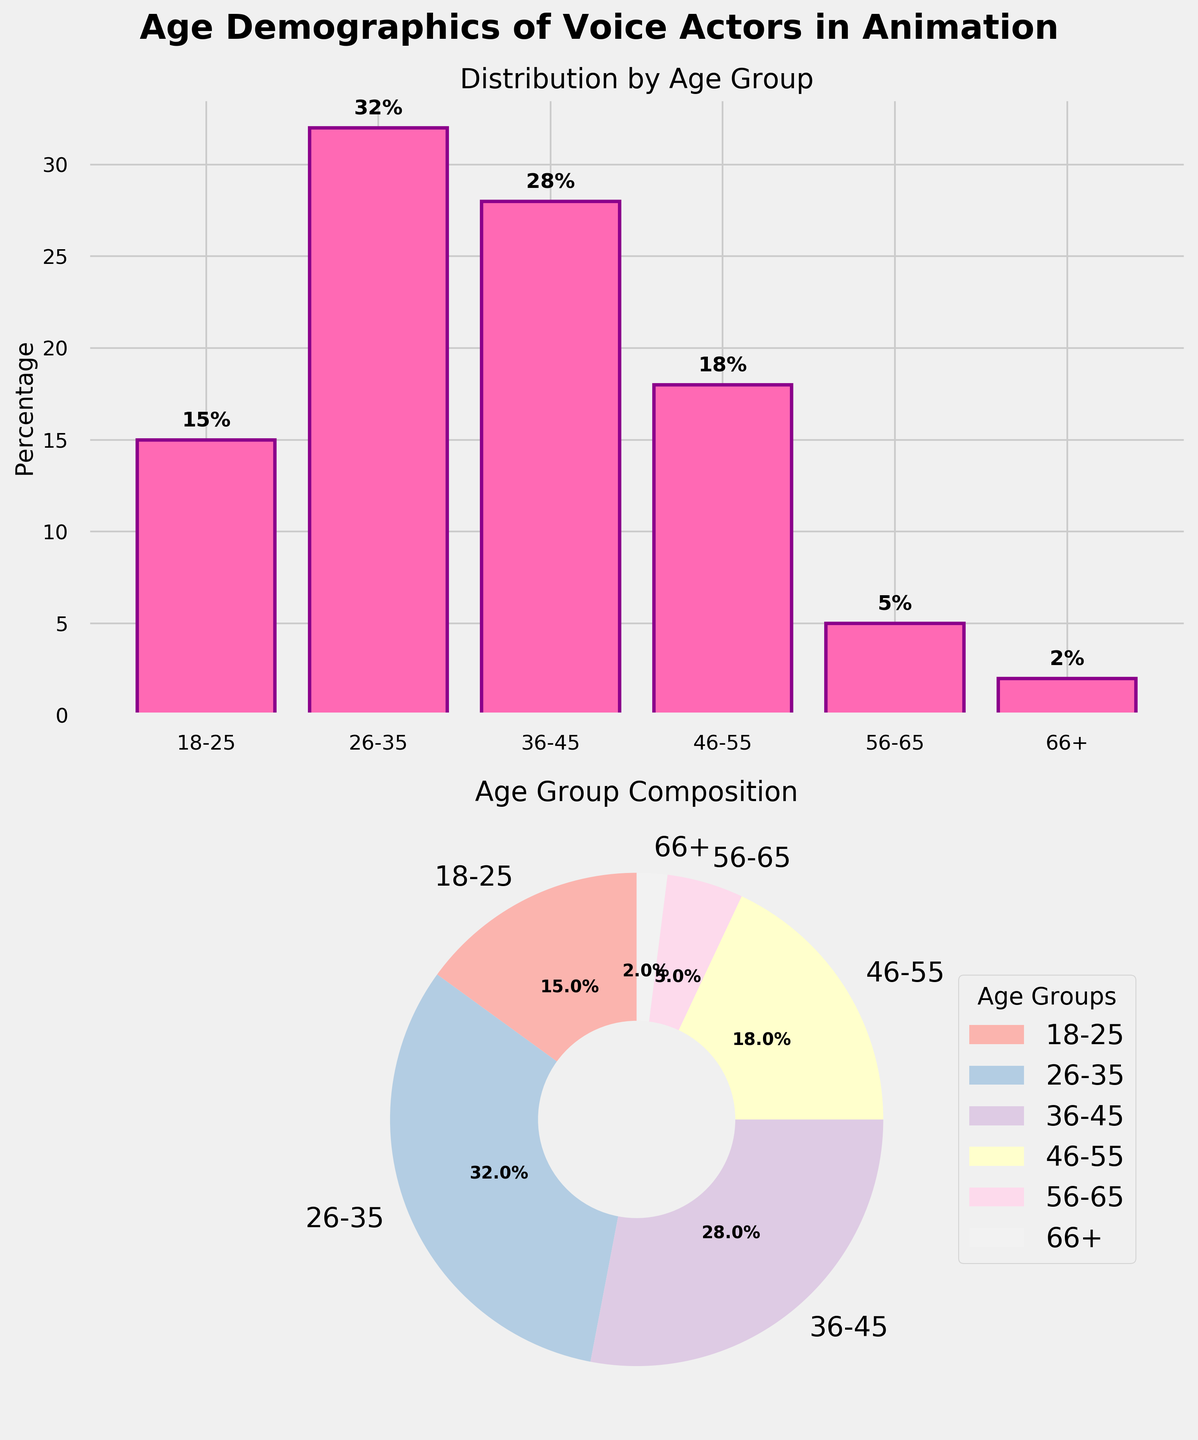What's the title of the figure? The title is generally located at the top of the figure. In this case, it is explicitly mentioned in the code that the title is "Age Demographics of Voice Actors in Animation".
Answer: Age Demographics of Voice Actors in Animation Which age group has the highest percentage? By looking at the bar plot, the tallest bar represents the age group with the highest percentage. Additionally, the pie chart percentage values indicate that the highest percentage belongs to the age group 26-35.
Answer: 26-35 What percentage of voice actors are 56-65 years old? Locate the bar corresponding to the age group 56-65 on the bar plot or look for the pie chart slice labeled 56-65. The percentage value next to it is 5%.
Answer: 5% How does the percentage of voice actors aged 18-25 compare to those aged 46-55? By comparing the heights of the bars or the slices in the pie chart, the bar corresponding to age 46-55 is taller and has a higher percentage value than the bar for age 18-25. Specifically, the percentages are 18% for 46-55 and 15% for 18-25.
Answer: 46-55 is higher What is the combined percentage of voice actors aged 36-45 and 46-55? Sum the percentages of the age groups 36-45 and 46-55. From the figure, 36-45 is 28% and 46-55 is 18%. Adding them gives 28% + 18% = 46%.
Answer: 46% Which age group makes up only 2% of the voice actors? Both the bar plot and the pie chart show an age group with a small slice or a short bar. The label on this smallest category indicates '66+' and is noted as 2%.
Answer: 66+ How is the data shown differently in the two subplots? The bar plot on the top subplot shows percentages as vertical bars with each bar's height representing the percentage. The pie chart on the bottom subplot shows the data as slices of a circle where each slice corresponds to a percentage and labels indicate the respective age group.
Answer: Bar plot and pie chart Which age group holds exactly 32% of the demographic? On the bar plot, find the bar with the label and height representing 32%. Alternatively, look for the segment in the pie chart labeled with 32%. Both show that the age group 26-35 holds 32%.
Answer: 26-35 What is the difference in percentage between the age groups 36-45 and 56-65? Subtract the percentage of the age group 56-65 from that of 36-45. The bar plot and pie chart both show that 36-45 is 28% and 56-65 is 5%. Therefore, 28% - 5% = 23%.
Answer: 23% What visual elements help in comparing the demographics between age groups? In both subplots, different colors and labels are used. The bar plot employs different bar heights and the pie chart uses distinct slices and colors to represent the age groups. Numeric labels on the bars and slices further assist in the comparison.
Answer: Colors, labels, bar heights, pie slices 